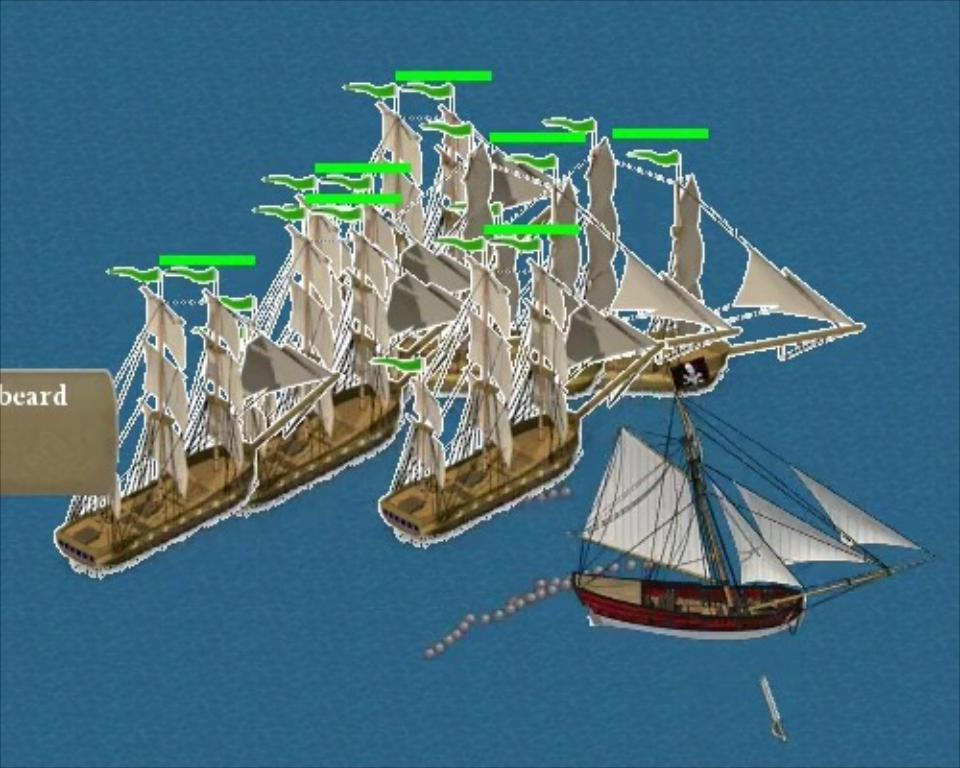What type of image is being described? The image is animated. What can be seen in the animated image? There are many boats in the image. Where is the kitty sitting in the image? There is no kitty present in the image; it only features boats. What is the condition of the throat of the person in the image? There is no person present in the image, only boats. 